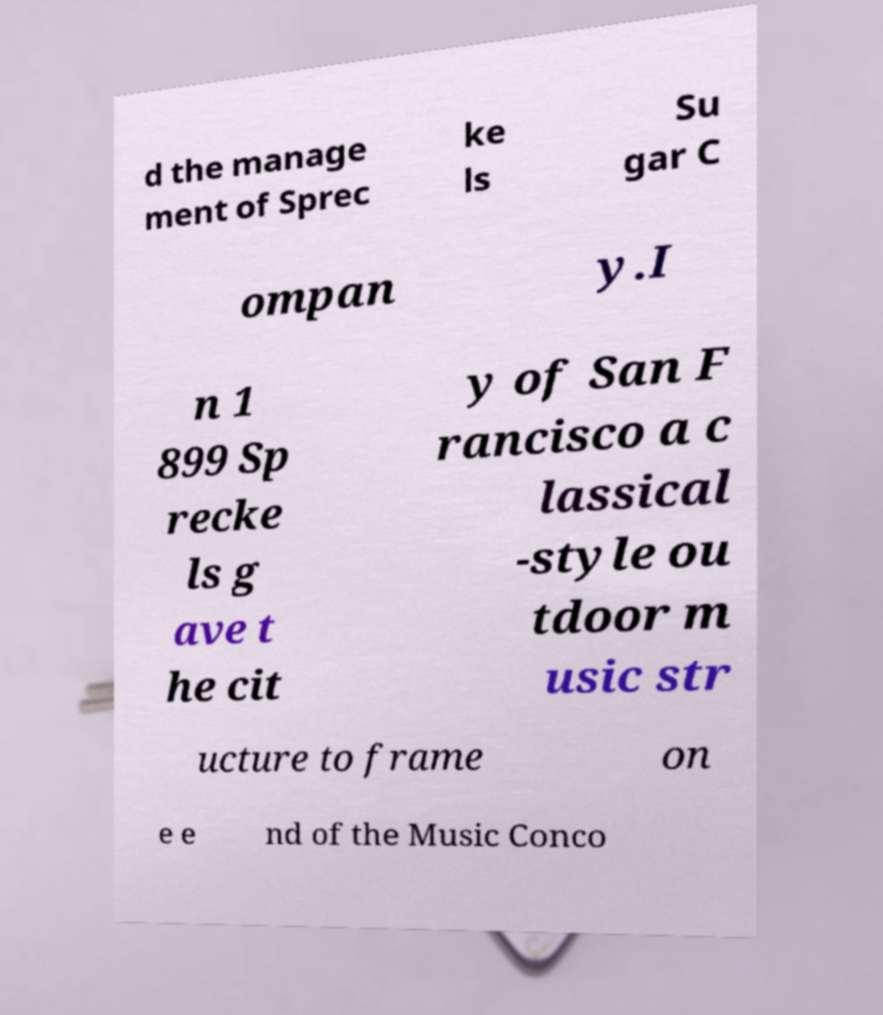Could you extract and type out the text from this image? d the manage ment of Sprec ke ls Su gar C ompan y.I n 1 899 Sp recke ls g ave t he cit y of San F rancisco a c lassical -style ou tdoor m usic str ucture to frame on e e nd of the Music Conco 